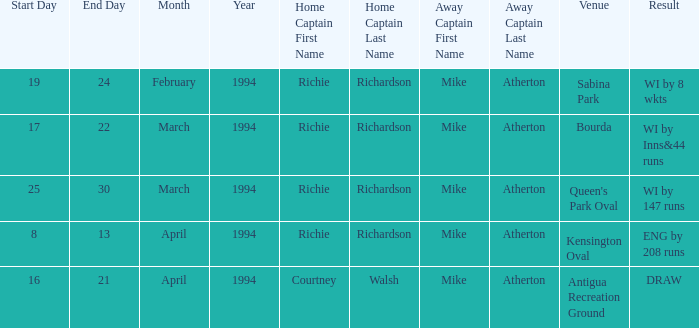What is the site that features a wi by 8 wkts? Sabina Park. 